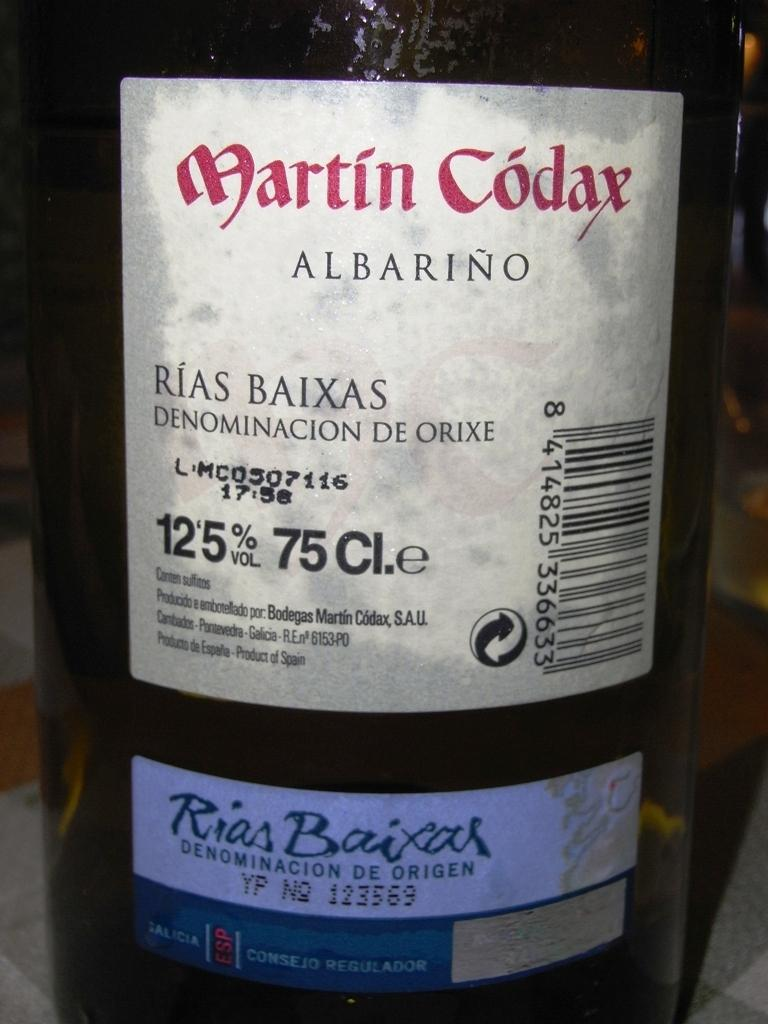Provide a one-sentence caption for the provided image. A bottle of wine with the label stating it is Martin Codax Albarino. 